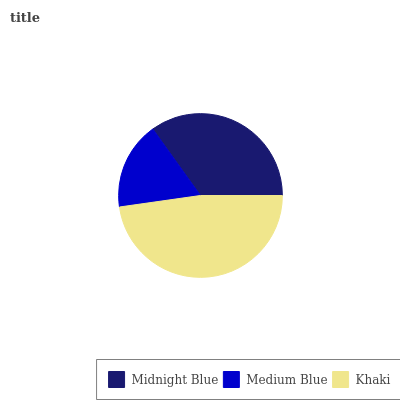Is Medium Blue the minimum?
Answer yes or no. Yes. Is Khaki the maximum?
Answer yes or no. Yes. Is Khaki the minimum?
Answer yes or no. No. Is Medium Blue the maximum?
Answer yes or no. No. Is Khaki greater than Medium Blue?
Answer yes or no. Yes. Is Medium Blue less than Khaki?
Answer yes or no. Yes. Is Medium Blue greater than Khaki?
Answer yes or no. No. Is Khaki less than Medium Blue?
Answer yes or no. No. Is Midnight Blue the high median?
Answer yes or no. Yes. Is Midnight Blue the low median?
Answer yes or no. Yes. Is Medium Blue the high median?
Answer yes or no. No. Is Khaki the low median?
Answer yes or no. No. 